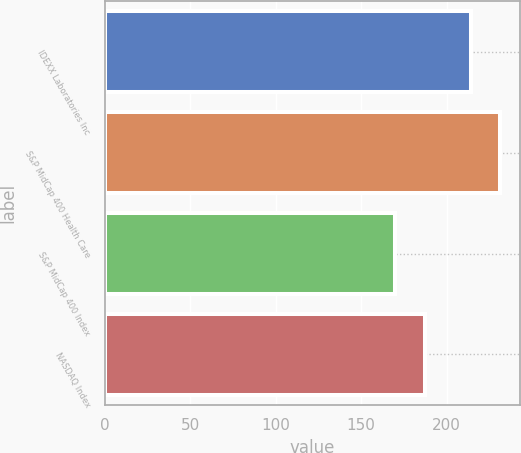<chart> <loc_0><loc_0><loc_500><loc_500><bar_chart><fcel>IDEXX Laboratories Inc<fcel>S&P MidCap 400 Health Care<fcel>S&P MidCap 400 Index<fcel>NASDAQ Index<nl><fcel>214.2<fcel>231.2<fcel>169.75<fcel>187.27<nl></chart> 